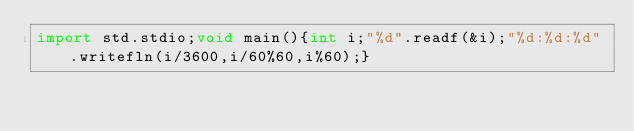Convert code to text. <code><loc_0><loc_0><loc_500><loc_500><_D_>import std.stdio;void main(){int i;"%d".readf(&i);"%d:%d:%d".writefln(i/3600,i/60%60,i%60);}</code> 